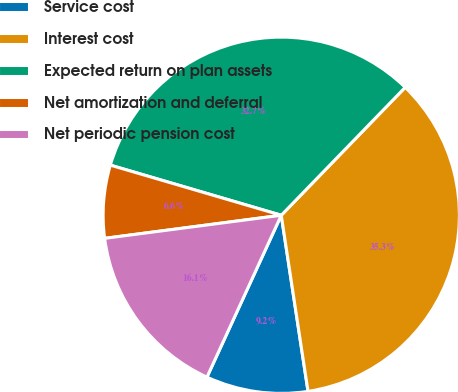Convert chart. <chart><loc_0><loc_0><loc_500><loc_500><pie_chart><fcel>Service cost<fcel>Interest cost<fcel>Expected return on plan assets<fcel>Net amortization and deferral<fcel>Net periodic pension cost<nl><fcel>9.25%<fcel>35.35%<fcel>32.71%<fcel>6.61%<fcel>16.08%<nl></chart> 